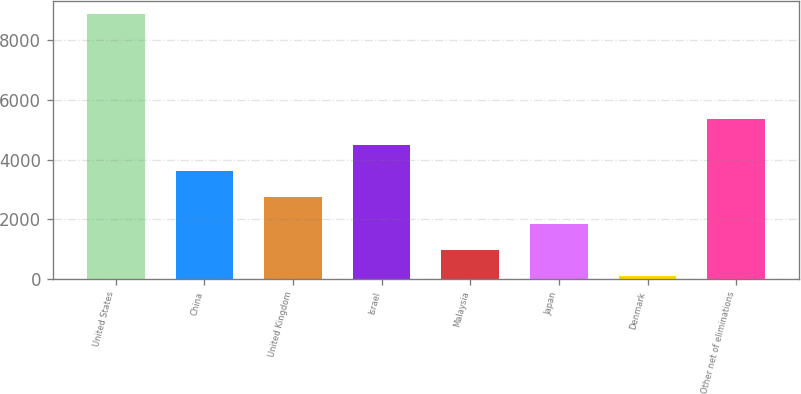Convert chart to OTSL. <chart><loc_0><loc_0><loc_500><loc_500><bar_chart><fcel>United States<fcel>China<fcel>United Kingdom<fcel>Israel<fcel>Malaysia<fcel>Japan<fcel>Denmark<fcel>Other net of eliminations<nl><fcel>8888<fcel>3611<fcel>2731.5<fcel>4490.5<fcel>972.5<fcel>1852<fcel>93<fcel>5370<nl></chart> 